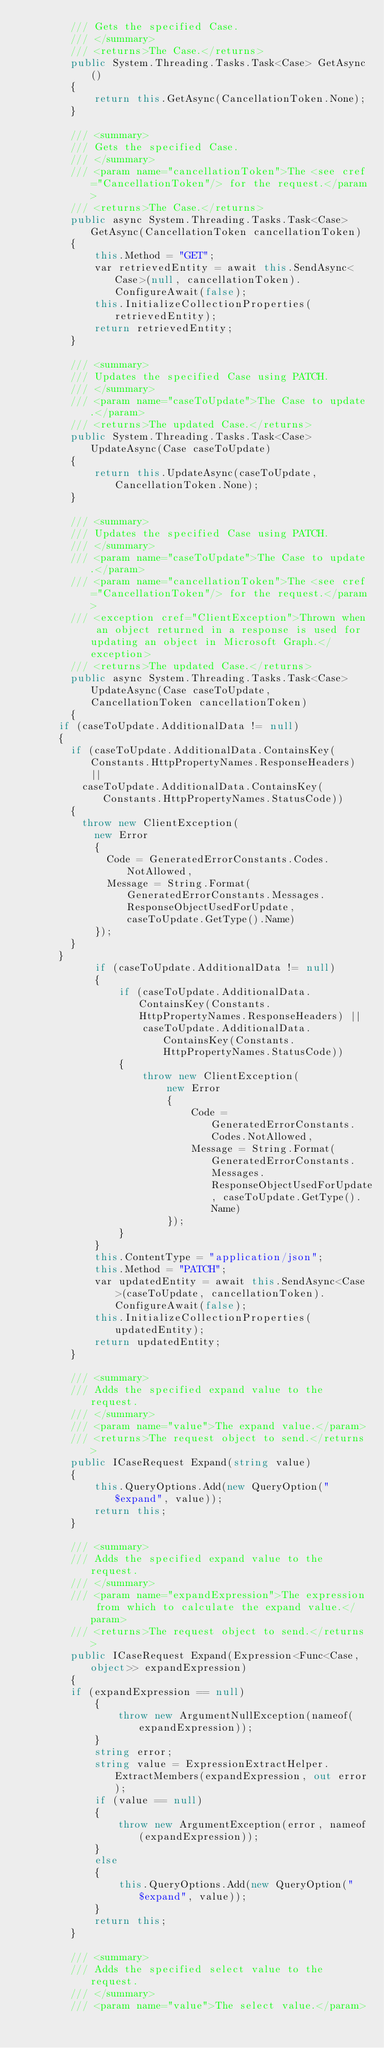Convert code to text. <code><loc_0><loc_0><loc_500><loc_500><_C#_>        /// Gets the specified Case.
        /// </summary>
        /// <returns>The Case.</returns>
        public System.Threading.Tasks.Task<Case> GetAsync()
        {
            return this.GetAsync(CancellationToken.None);
        }

        /// <summary>
        /// Gets the specified Case.
        /// </summary>
        /// <param name="cancellationToken">The <see cref="CancellationToken"/> for the request.</param>
        /// <returns>The Case.</returns>
        public async System.Threading.Tasks.Task<Case> GetAsync(CancellationToken cancellationToken)
        {
            this.Method = "GET";
            var retrievedEntity = await this.SendAsync<Case>(null, cancellationToken).ConfigureAwait(false);
            this.InitializeCollectionProperties(retrievedEntity);
            return retrievedEntity;
        }

        /// <summary>
        /// Updates the specified Case using PATCH.
        /// </summary>
        /// <param name="caseToUpdate">The Case to update.</param>
        /// <returns>The updated Case.</returns>
        public System.Threading.Tasks.Task<Case> UpdateAsync(Case caseToUpdate)
        {
            return this.UpdateAsync(caseToUpdate, CancellationToken.None);
        }

        /// <summary>
        /// Updates the specified Case using PATCH.
        /// </summary>
        /// <param name="caseToUpdate">The Case to update.</param>
        /// <param name="cancellationToken">The <see cref="CancellationToken"/> for the request.</param>
        /// <exception cref="ClientException">Thrown when an object returned in a response is used for updating an object in Microsoft Graph.</exception>
        /// <returns>The updated Case.</returns>
        public async System.Threading.Tasks.Task<Case> UpdateAsync(Case caseToUpdate, CancellationToken cancellationToken)
        {
			if (caseToUpdate.AdditionalData != null)
			{
				if (caseToUpdate.AdditionalData.ContainsKey(Constants.HttpPropertyNames.ResponseHeaders) ||
					caseToUpdate.AdditionalData.ContainsKey(Constants.HttpPropertyNames.StatusCode))
				{
					throw new ClientException(
						new Error
						{
							Code = GeneratedErrorConstants.Codes.NotAllowed,
							Message = String.Format(GeneratedErrorConstants.Messages.ResponseObjectUsedForUpdate, caseToUpdate.GetType().Name)
						});
				}
			}
            if (caseToUpdate.AdditionalData != null)
            {
                if (caseToUpdate.AdditionalData.ContainsKey(Constants.HttpPropertyNames.ResponseHeaders) ||
                    caseToUpdate.AdditionalData.ContainsKey(Constants.HttpPropertyNames.StatusCode))
                {
                    throw new ClientException(
                        new Error
                        {
                            Code = GeneratedErrorConstants.Codes.NotAllowed,
                            Message = String.Format(GeneratedErrorConstants.Messages.ResponseObjectUsedForUpdate, caseToUpdate.GetType().Name)
                        });
                }
            }
            this.ContentType = "application/json";
            this.Method = "PATCH";
            var updatedEntity = await this.SendAsync<Case>(caseToUpdate, cancellationToken).ConfigureAwait(false);
            this.InitializeCollectionProperties(updatedEntity);
            return updatedEntity;
        }

        /// <summary>
        /// Adds the specified expand value to the request.
        /// </summary>
        /// <param name="value">The expand value.</param>
        /// <returns>The request object to send.</returns>
        public ICaseRequest Expand(string value)
        {
            this.QueryOptions.Add(new QueryOption("$expand", value));
            return this;
        }

        /// <summary>
        /// Adds the specified expand value to the request.
        /// </summary>
        /// <param name="expandExpression">The expression from which to calculate the expand value.</param>
        /// <returns>The request object to send.</returns>
        public ICaseRequest Expand(Expression<Func<Case, object>> expandExpression)
        {
		    if (expandExpression == null)
            {
                throw new ArgumentNullException(nameof(expandExpression));
            }
            string error;
            string value = ExpressionExtractHelper.ExtractMembers(expandExpression, out error);
            if (value == null)
            {
                throw new ArgumentException(error, nameof(expandExpression));
            }
            else
            {
                this.QueryOptions.Add(new QueryOption("$expand", value));
            }
            return this;
        }

        /// <summary>
        /// Adds the specified select value to the request.
        /// </summary>
        /// <param name="value">The select value.</param></code> 